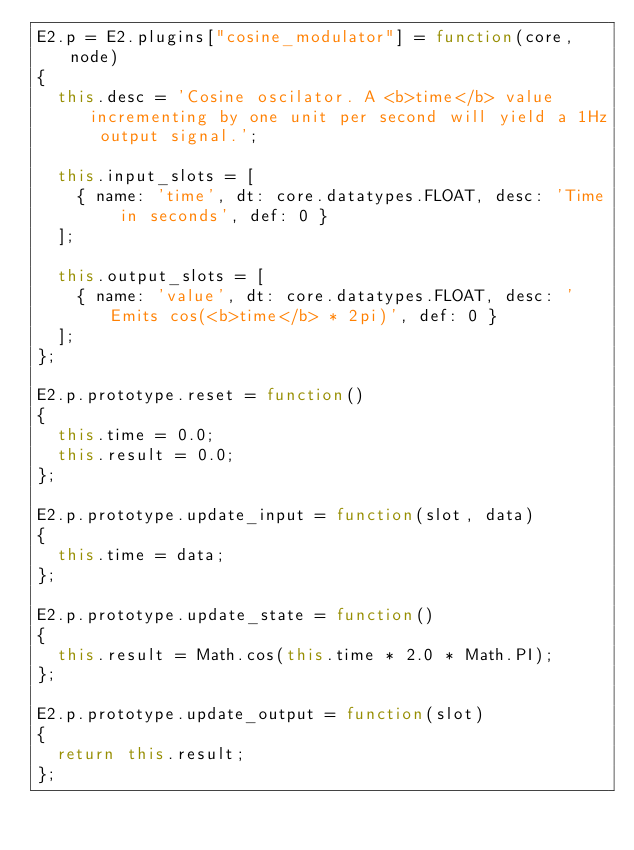Convert code to text. <code><loc_0><loc_0><loc_500><loc_500><_JavaScript_>E2.p = E2.plugins["cosine_modulator"] = function(core, node)
{
	this.desc = 'Cosine oscilator. A <b>time</b> value incrementing by one unit per second will yield a 1Hz output signal.';
	
	this.input_slots = [
		{ name: 'time', dt: core.datatypes.FLOAT, desc: 'Time in seconds', def: 0 }
	];
	
	this.output_slots = [
		{ name: 'value', dt: core.datatypes.FLOAT, desc: 'Emits cos(<b>time</b> * 2pi)', def: 0 }
	];
};

E2.p.prototype.reset = function()
{
	this.time = 0.0;
	this.result = 0.0;
};

E2.p.prototype.update_input = function(slot, data)
{
	this.time = data;
};	

E2.p.prototype.update_state = function()
{
	this.result = Math.cos(this.time * 2.0 * Math.PI);
};

E2.p.prototype.update_output = function(slot)
{
	return this.result;
};
</code> 